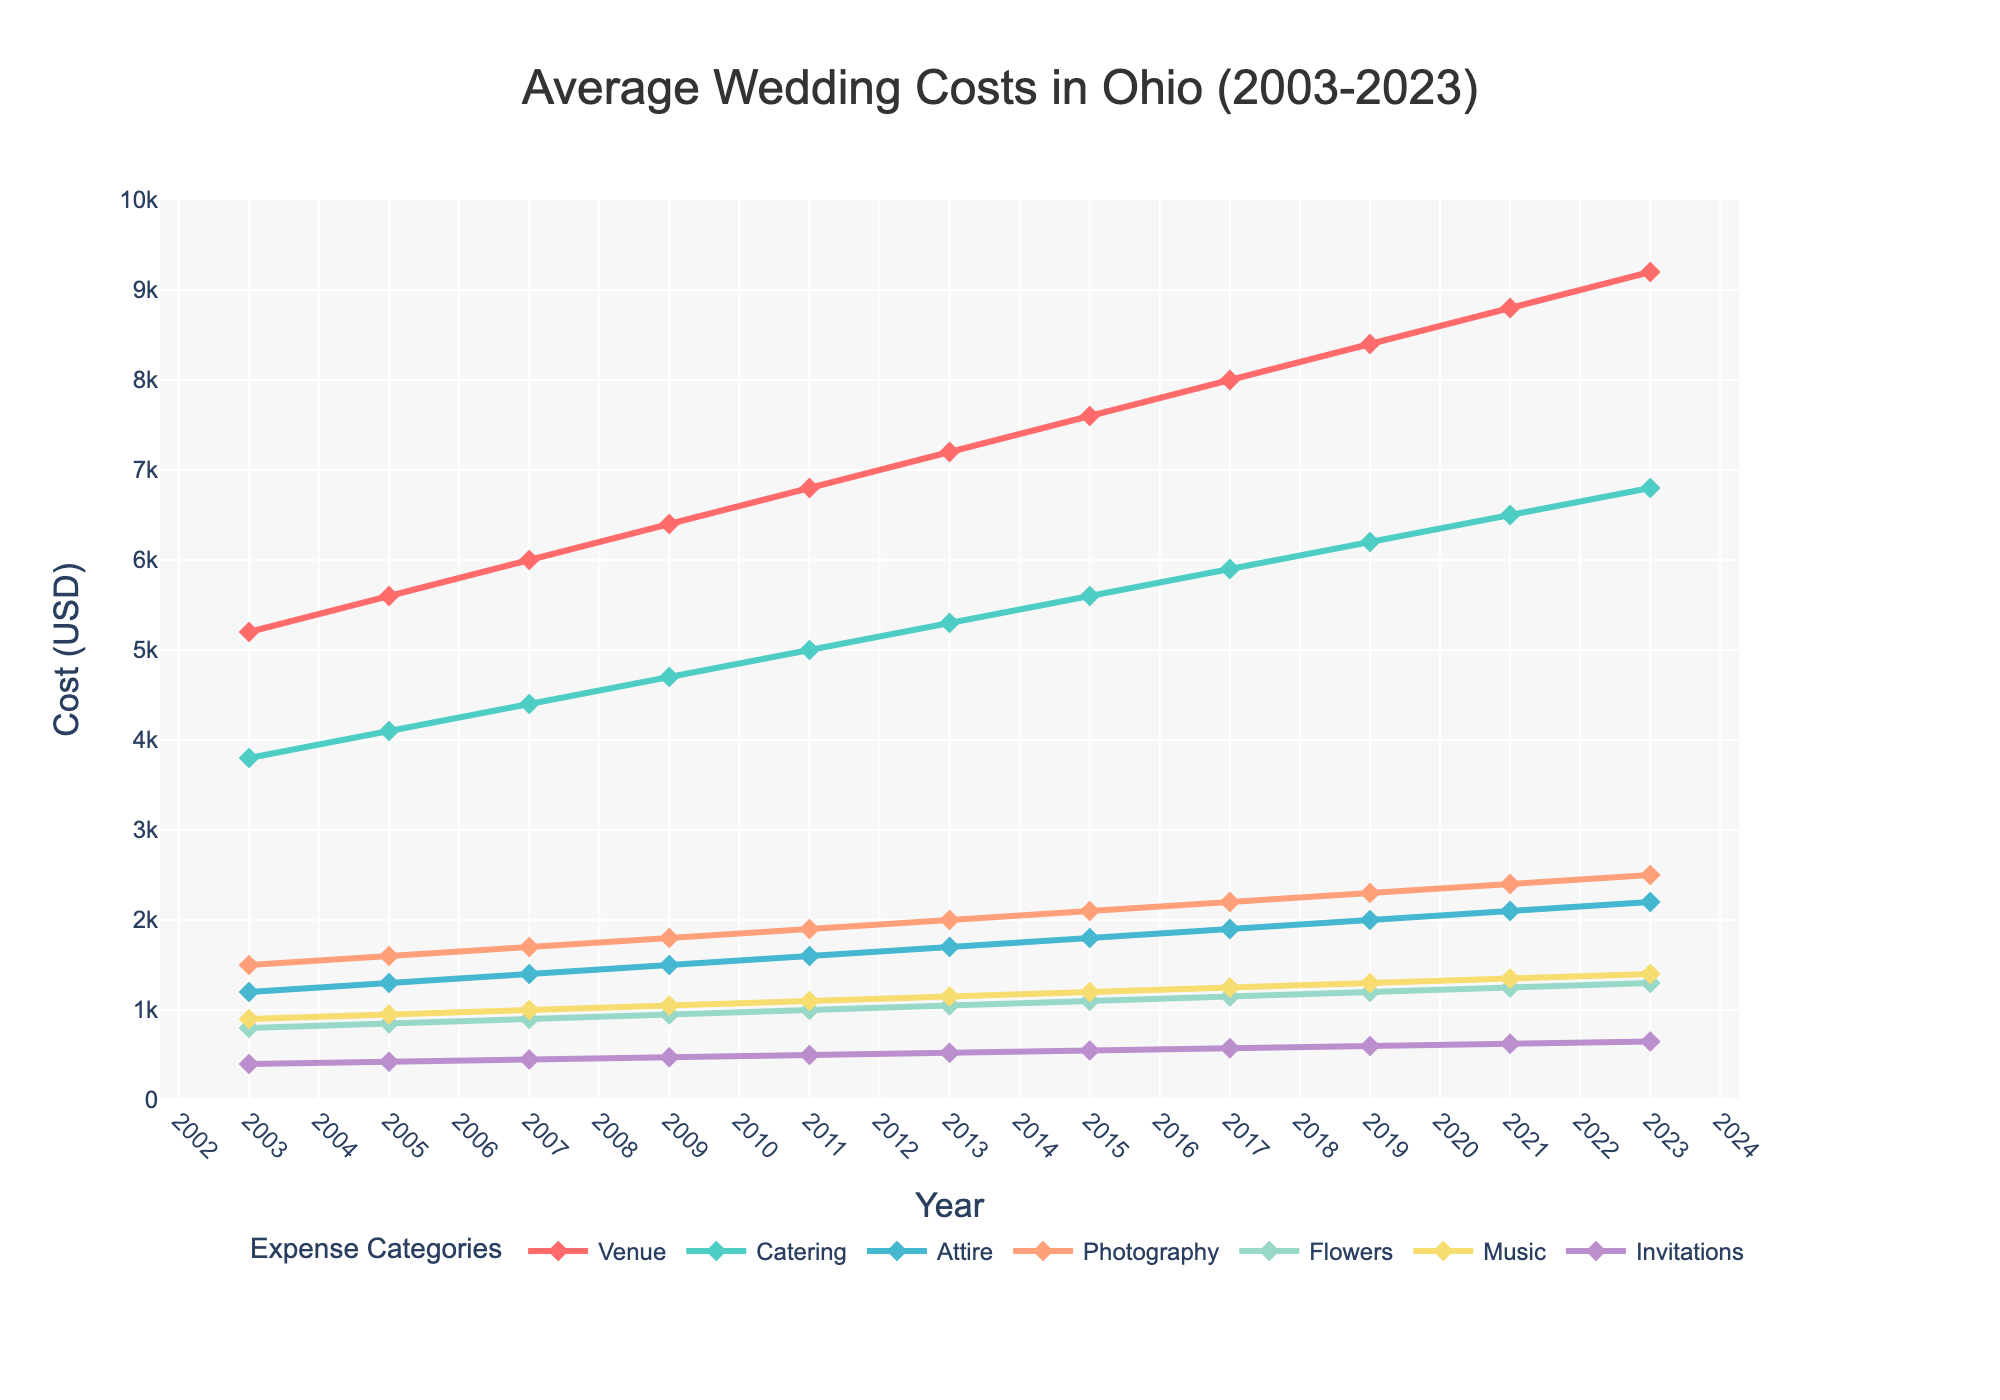What's the average venue cost over the 20 years? To find the average venue cost, sum up all the venue costs from 2003 to 2023 and divide by the number of years. (5200 + 5600 + 6000 + 6400 + 6800 + 7200 + 7600 + 8000 + 8400 + 8800 + 9200) / 11 = 7045.45
Answer: 7045.45 In which year was the catering cost highest? The highest catering cost can be identified by locating the maximum value in the catering data series. The maximum value is 6800 in 2023.
Answer: 2023 How does the cost of flowers in 2021 compare to that in 2003? To compare the flower costs of 2021 and 2003, find the values for these years and calculate the difference. The cost in 2003 was 800 and in 2021 it was 1250. The difference is 1250 - 800 = 450.
Answer: 450 What is the trend in music costs from 2003 to 2023? To determine the trend, observe the change in values from 2003 to 2023. Music costs start at 900 in 2003 and gradually increase to 1400 in 2023, indicating a steady upward trend.
Answer: Steady upward trend Which expense category saw the largest increase from 2003 to 2023? Calculate the increase for each category by subtracting the 2003 value from the 2023 value: Venue: 9200-5200=4000, Catering: 6800-3800=3000, Attire: 2200-1200=1000, Photography: 2500-1500=1000, Flowers: 1300-800=500, Music: 1400-900=500, Invitations: 650-400=250. The largest increase is in Venue costs with a difference of 4000.
Answer: Venue What is the overall average increase per year for photography costs? The overall increase for photography costs from 2003 (1500) to 2023 (2500) is 2500 - 1500 = 1000. There are 20 years in this span, so the average increase per year is 1000 / 20 = 50.
Answer: 50 Compare the rate of increase of catering costs to that of music costs over 20 years. For Catering: (6800 - 3800) / 20 = 150, For Music: (1400 - 900) / 20 = 25. Catering costs increase by 150 per year, while Music costs increase by 25 per year.
Answer: Catering has a higher rate of increase What is the total cost for all expense categories in 2015? Sum up all expense categories for the year 2015: 7600 (Venue) + 5600 (Catering) + 1800 (Attire) + 2100 (Photography) + 1100 (Flowers) + 1200 (Music) + 550 (Invitations) = 19950
Answer: 19950 